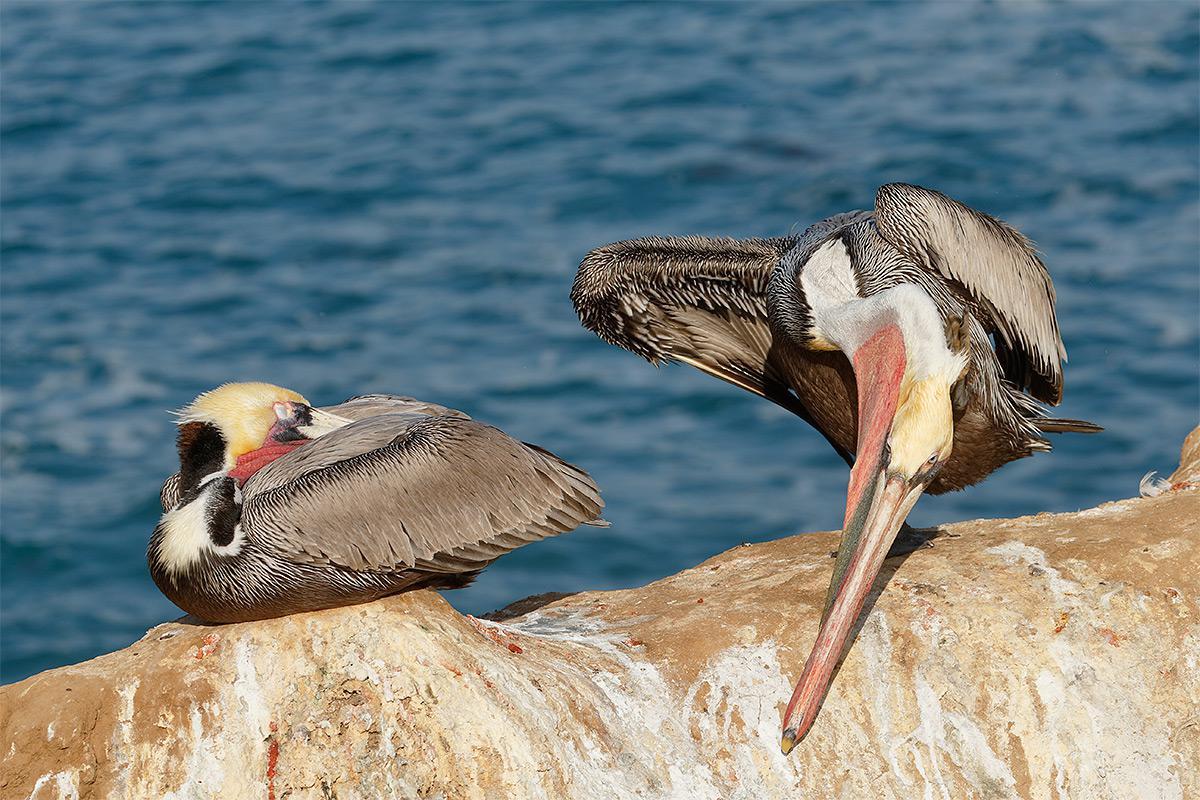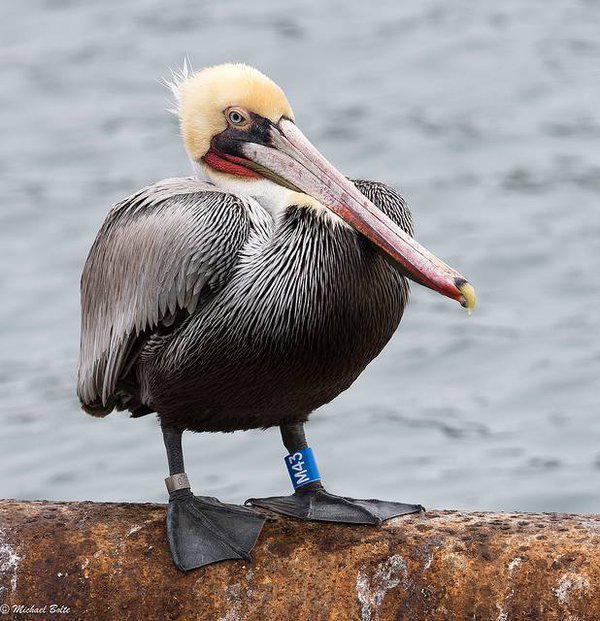The first image is the image on the left, the second image is the image on the right. For the images shown, is this caption "Each image shows a single pelican standing on its legs." true? Answer yes or no. No. 